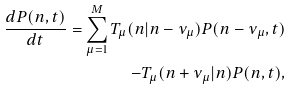<formula> <loc_0><loc_0><loc_500><loc_500>\frac { d P ( n , t ) } { d t } = \sum ^ { M } _ { \mu = 1 } T _ { \mu } ( n | n - \nu _ { \mu } ) P ( n - \nu _ { \mu } , t ) \\ - T _ { \mu } ( n + \nu _ { \mu } | n ) P ( n , t ) ,</formula> 